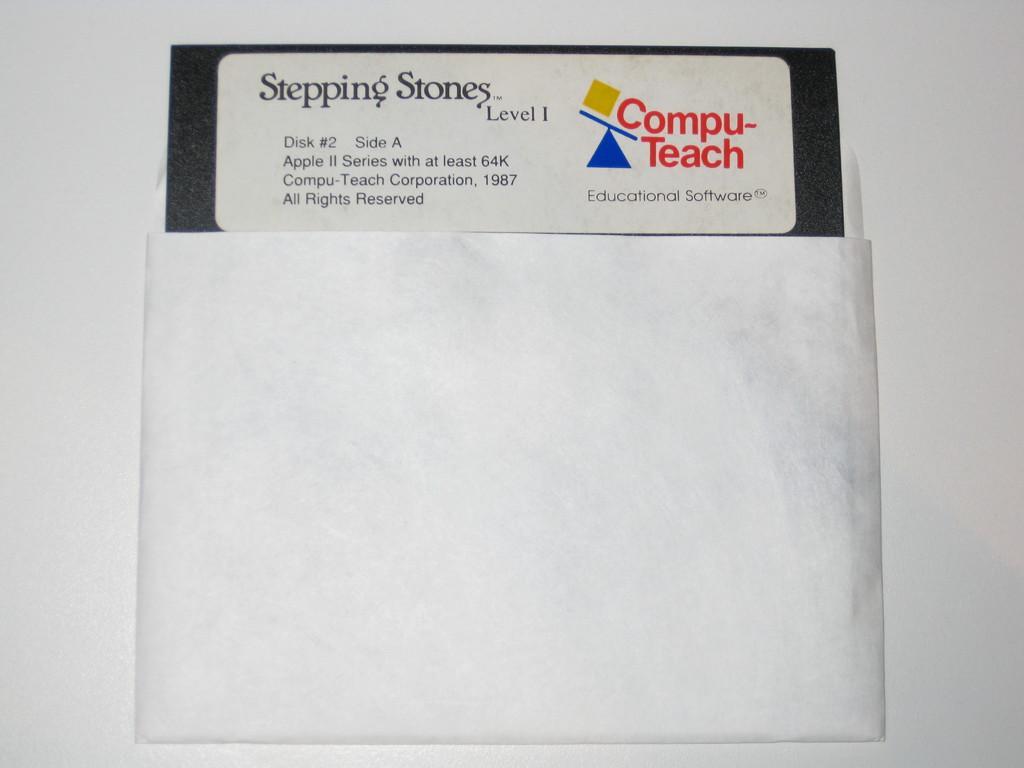In one or two sentences, can you explain what this image depicts? In this picture it looks like a white envelope with a pamphlet inside it. 